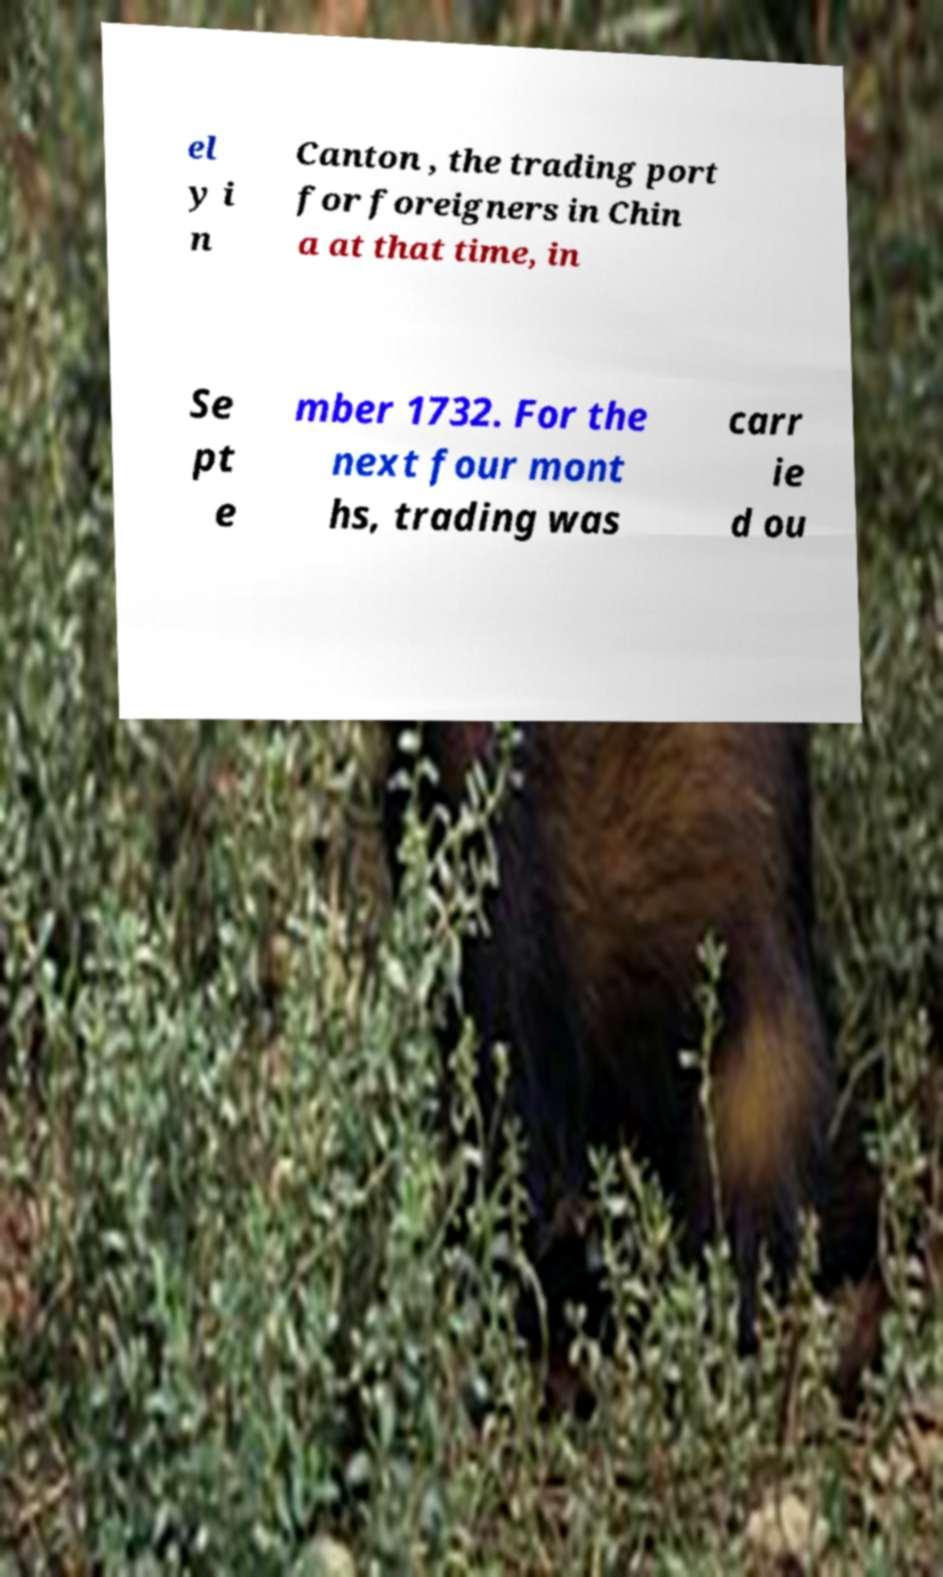Please identify and transcribe the text found in this image. el y i n Canton , the trading port for foreigners in Chin a at that time, in Se pt e mber 1732. For the next four mont hs, trading was carr ie d ou 